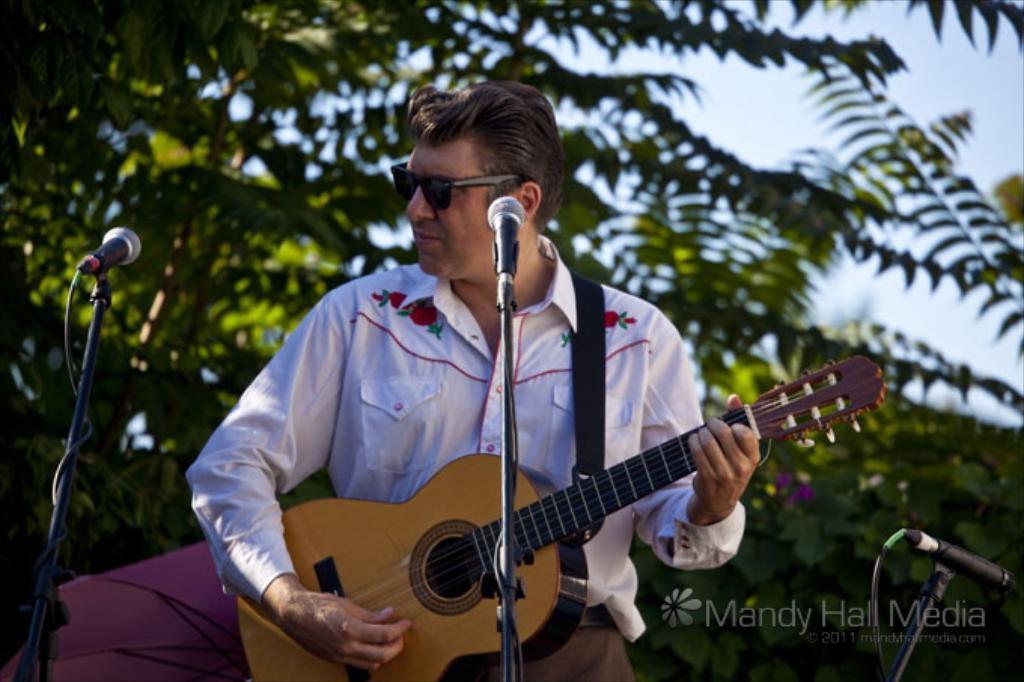Please provide a concise description of this image. There is a man standing and in front of microphone and playing guitar. Behind him there are lot of trees. 